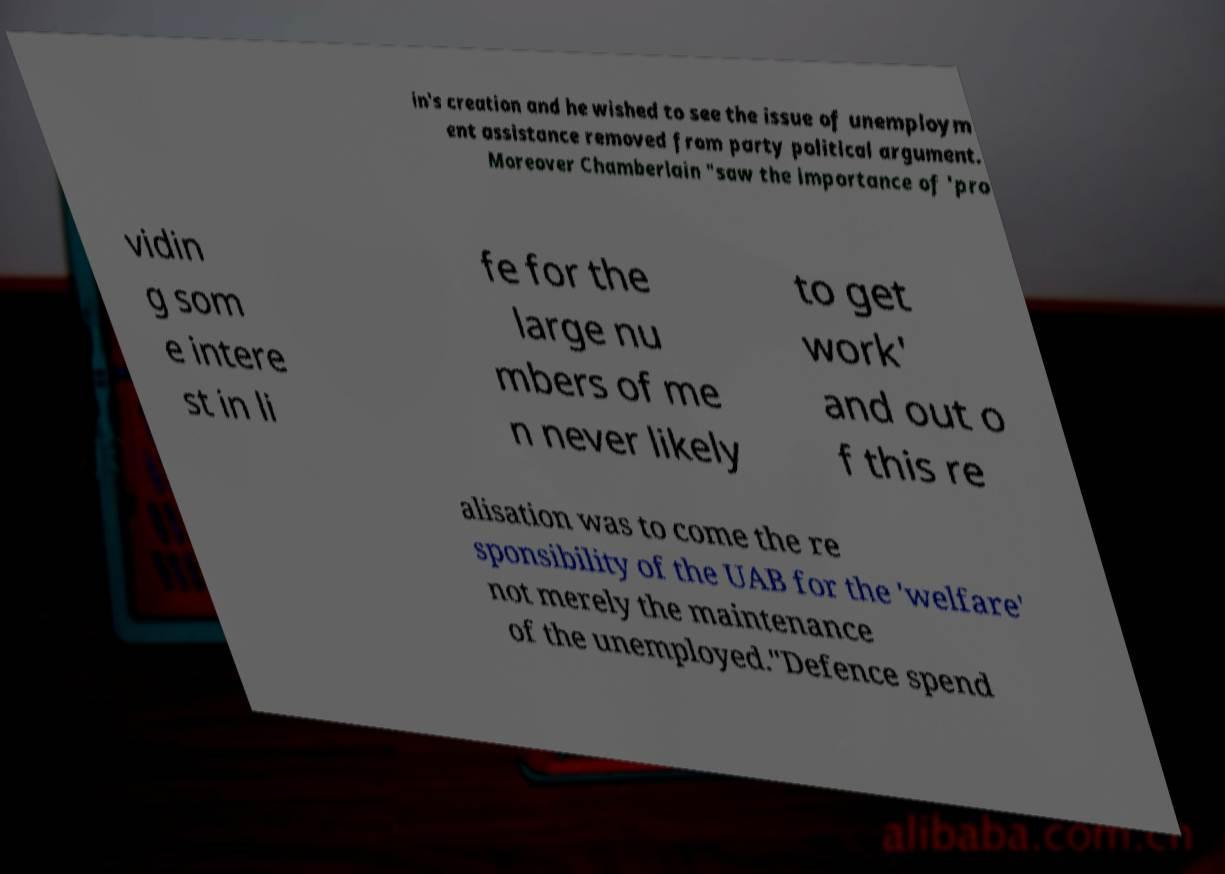I need the written content from this picture converted into text. Can you do that? in's creation and he wished to see the issue of unemploym ent assistance removed from party political argument. Moreover Chamberlain "saw the importance of 'pro vidin g som e intere st in li fe for the large nu mbers of me n never likely to get work' and out o f this re alisation was to come the re sponsibility of the UAB for the 'welfare' not merely the maintenance of the unemployed."Defence spend 